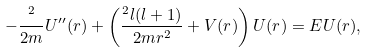<formula> <loc_0><loc_0><loc_500><loc_500>- \frac { { } ^ { 2 } } { 2 m } U ^ { \prime \prime } ( r ) + \left ( { \frac { { } ^ { 2 } l ( l + 1 ) } { 2 m r ^ { 2 } } + V ( r ) } \right ) U ( r ) = E U ( r ) ,</formula> 